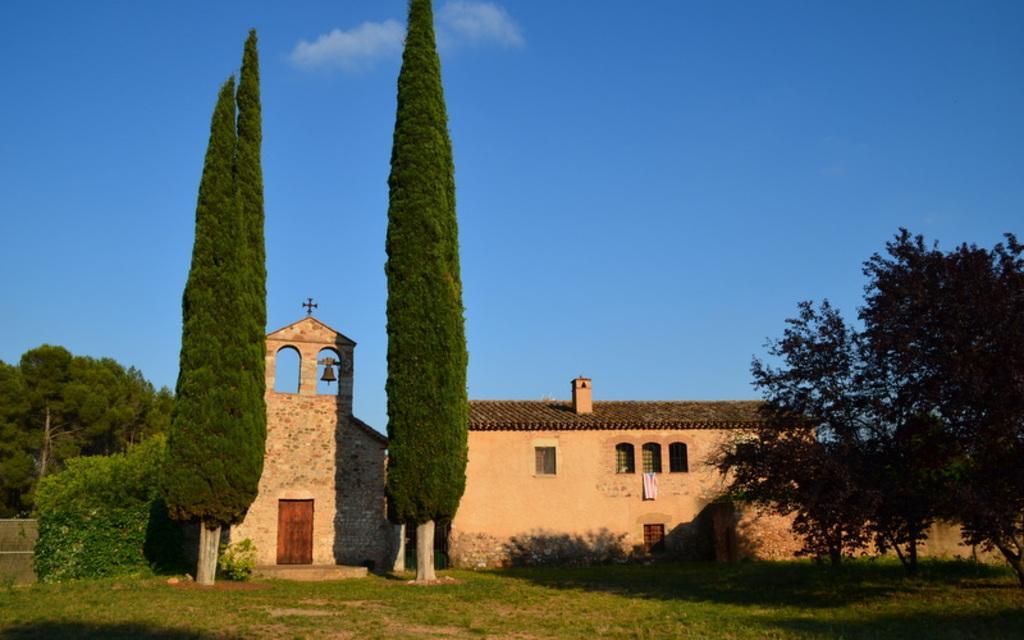Can you describe this image briefly? In the center of the image there are buildings and we can see trees. In the background there is sky. 